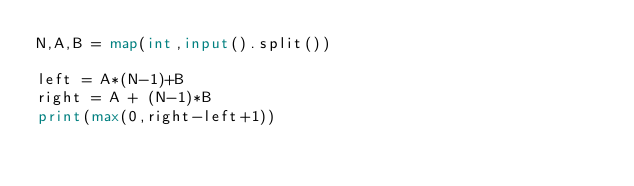Convert code to text. <code><loc_0><loc_0><loc_500><loc_500><_Python_>N,A,B = map(int,input().split())

left = A*(N-1)+B
right = A + (N-1)*B
print(max(0,right-left+1))</code> 